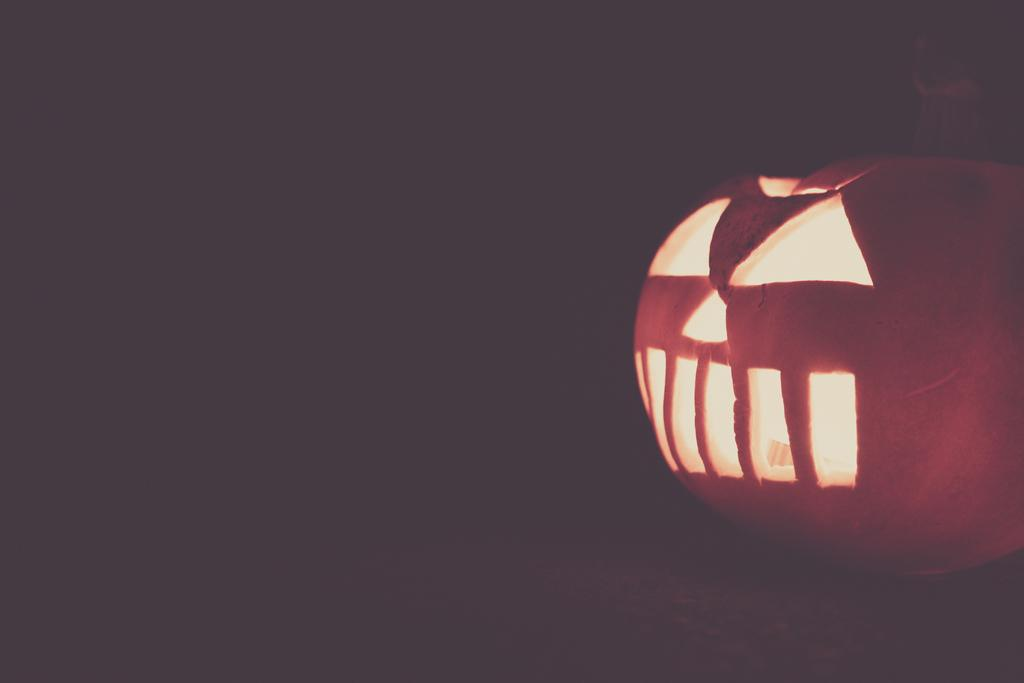What object is located on the right side of the image? There is a pumpkin on the right side of the image. What color is the background of the image? The background of the image is black. What word is written on the pumpkin in the image? There are no words written on the pumpkin in the image. What rule is being enforced by the pumpkin in the image? The pumpkin is not enforcing any rules in the image; it is simply an object. 